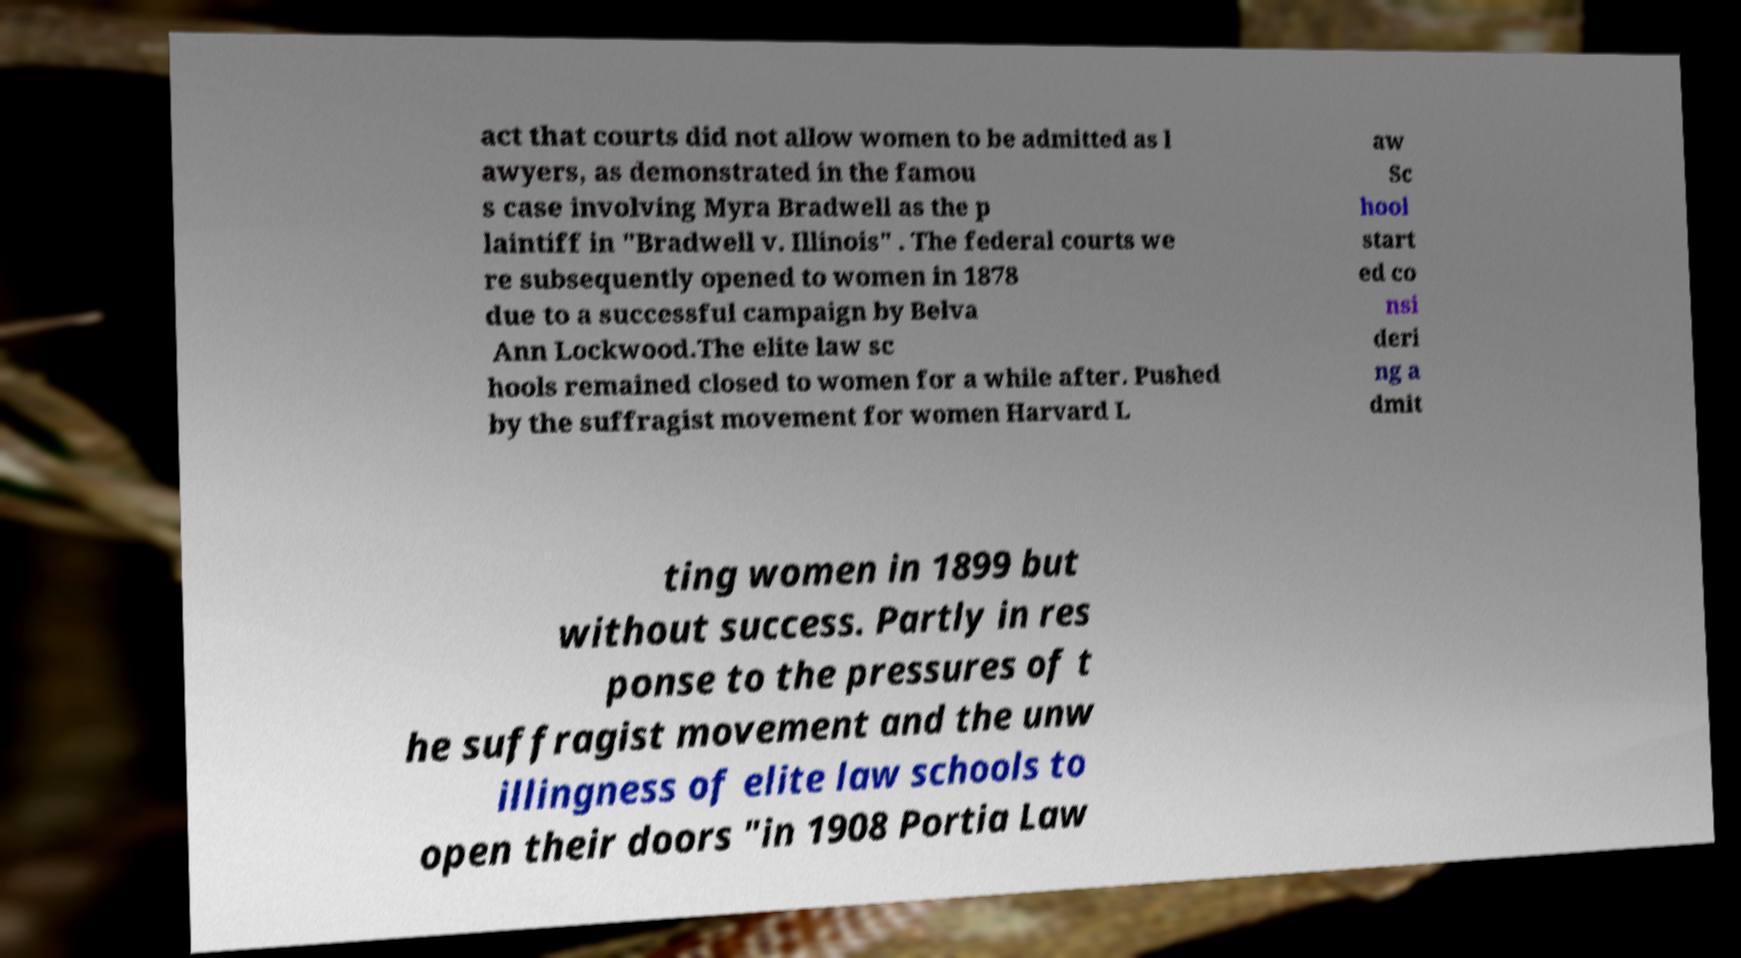What messages or text are displayed in this image? I need them in a readable, typed format. act that courts did not allow women to be admitted as l awyers, as demonstrated in the famou s case involving Myra Bradwell as the p laintiff in "Bradwell v. Illinois" . The federal courts we re subsequently opened to women in 1878 due to a successful campaign by Belva Ann Lockwood.The elite law sc hools remained closed to women for a while after. Pushed by the suffragist movement for women Harvard L aw Sc hool start ed co nsi deri ng a dmit ting women in 1899 but without success. Partly in res ponse to the pressures of t he suffragist movement and the unw illingness of elite law schools to open their doors "in 1908 Portia Law 